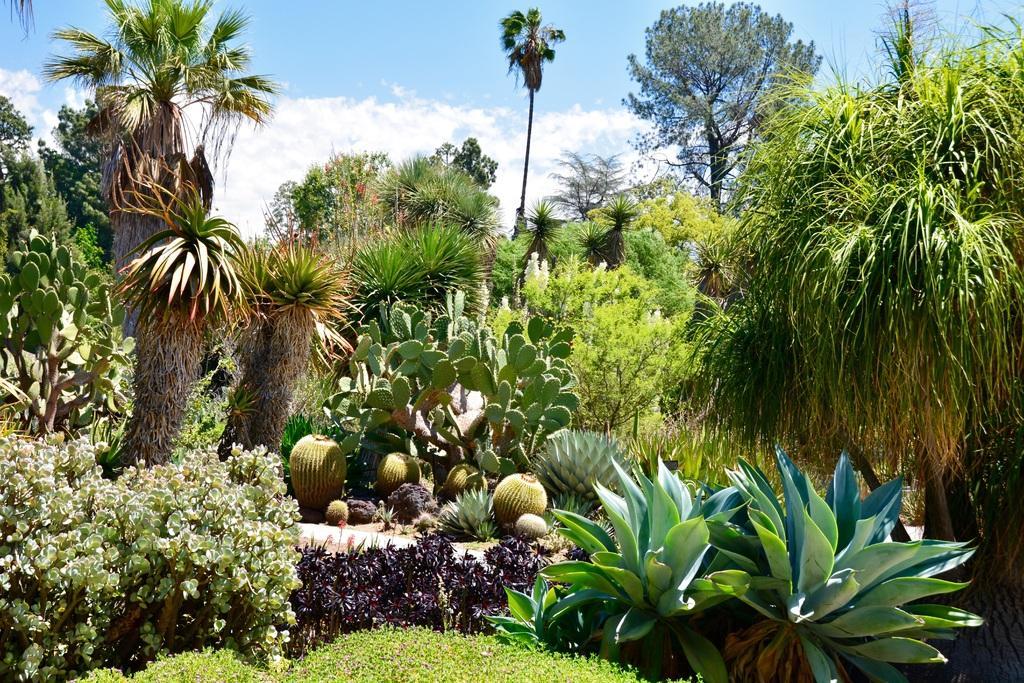Can you describe this image briefly? In this picture we can see few plants, trees and clouds. 